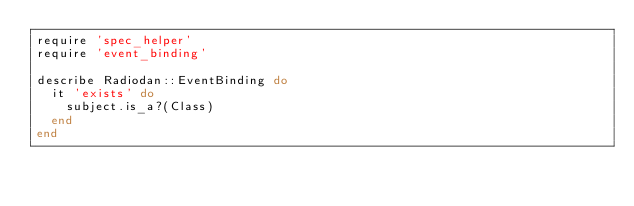<code> <loc_0><loc_0><loc_500><loc_500><_Ruby_>require 'spec_helper'
require 'event_binding'

describe Radiodan::EventBinding do
  it 'exists' do
    subject.is_a?(Class)
  end
end
</code> 